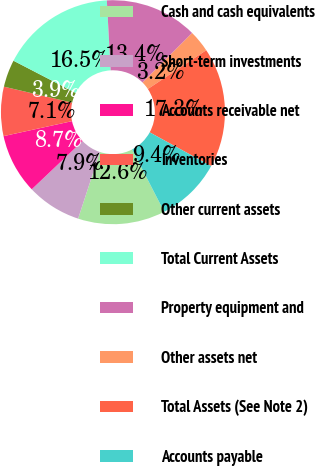Convert chart. <chart><loc_0><loc_0><loc_500><loc_500><pie_chart><fcel>Cash and cash equivalents<fcel>Short-term investments<fcel>Accounts receivable net<fcel>Inventories<fcel>Other current assets<fcel>Total Current Assets<fcel>Property equipment and<fcel>Other assets net<fcel>Total Assets (See Note 2)<fcel>Accounts payable<nl><fcel>12.6%<fcel>7.88%<fcel>8.66%<fcel>7.09%<fcel>3.94%<fcel>16.53%<fcel>13.38%<fcel>3.16%<fcel>17.32%<fcel>9.45%<nl></chart> 